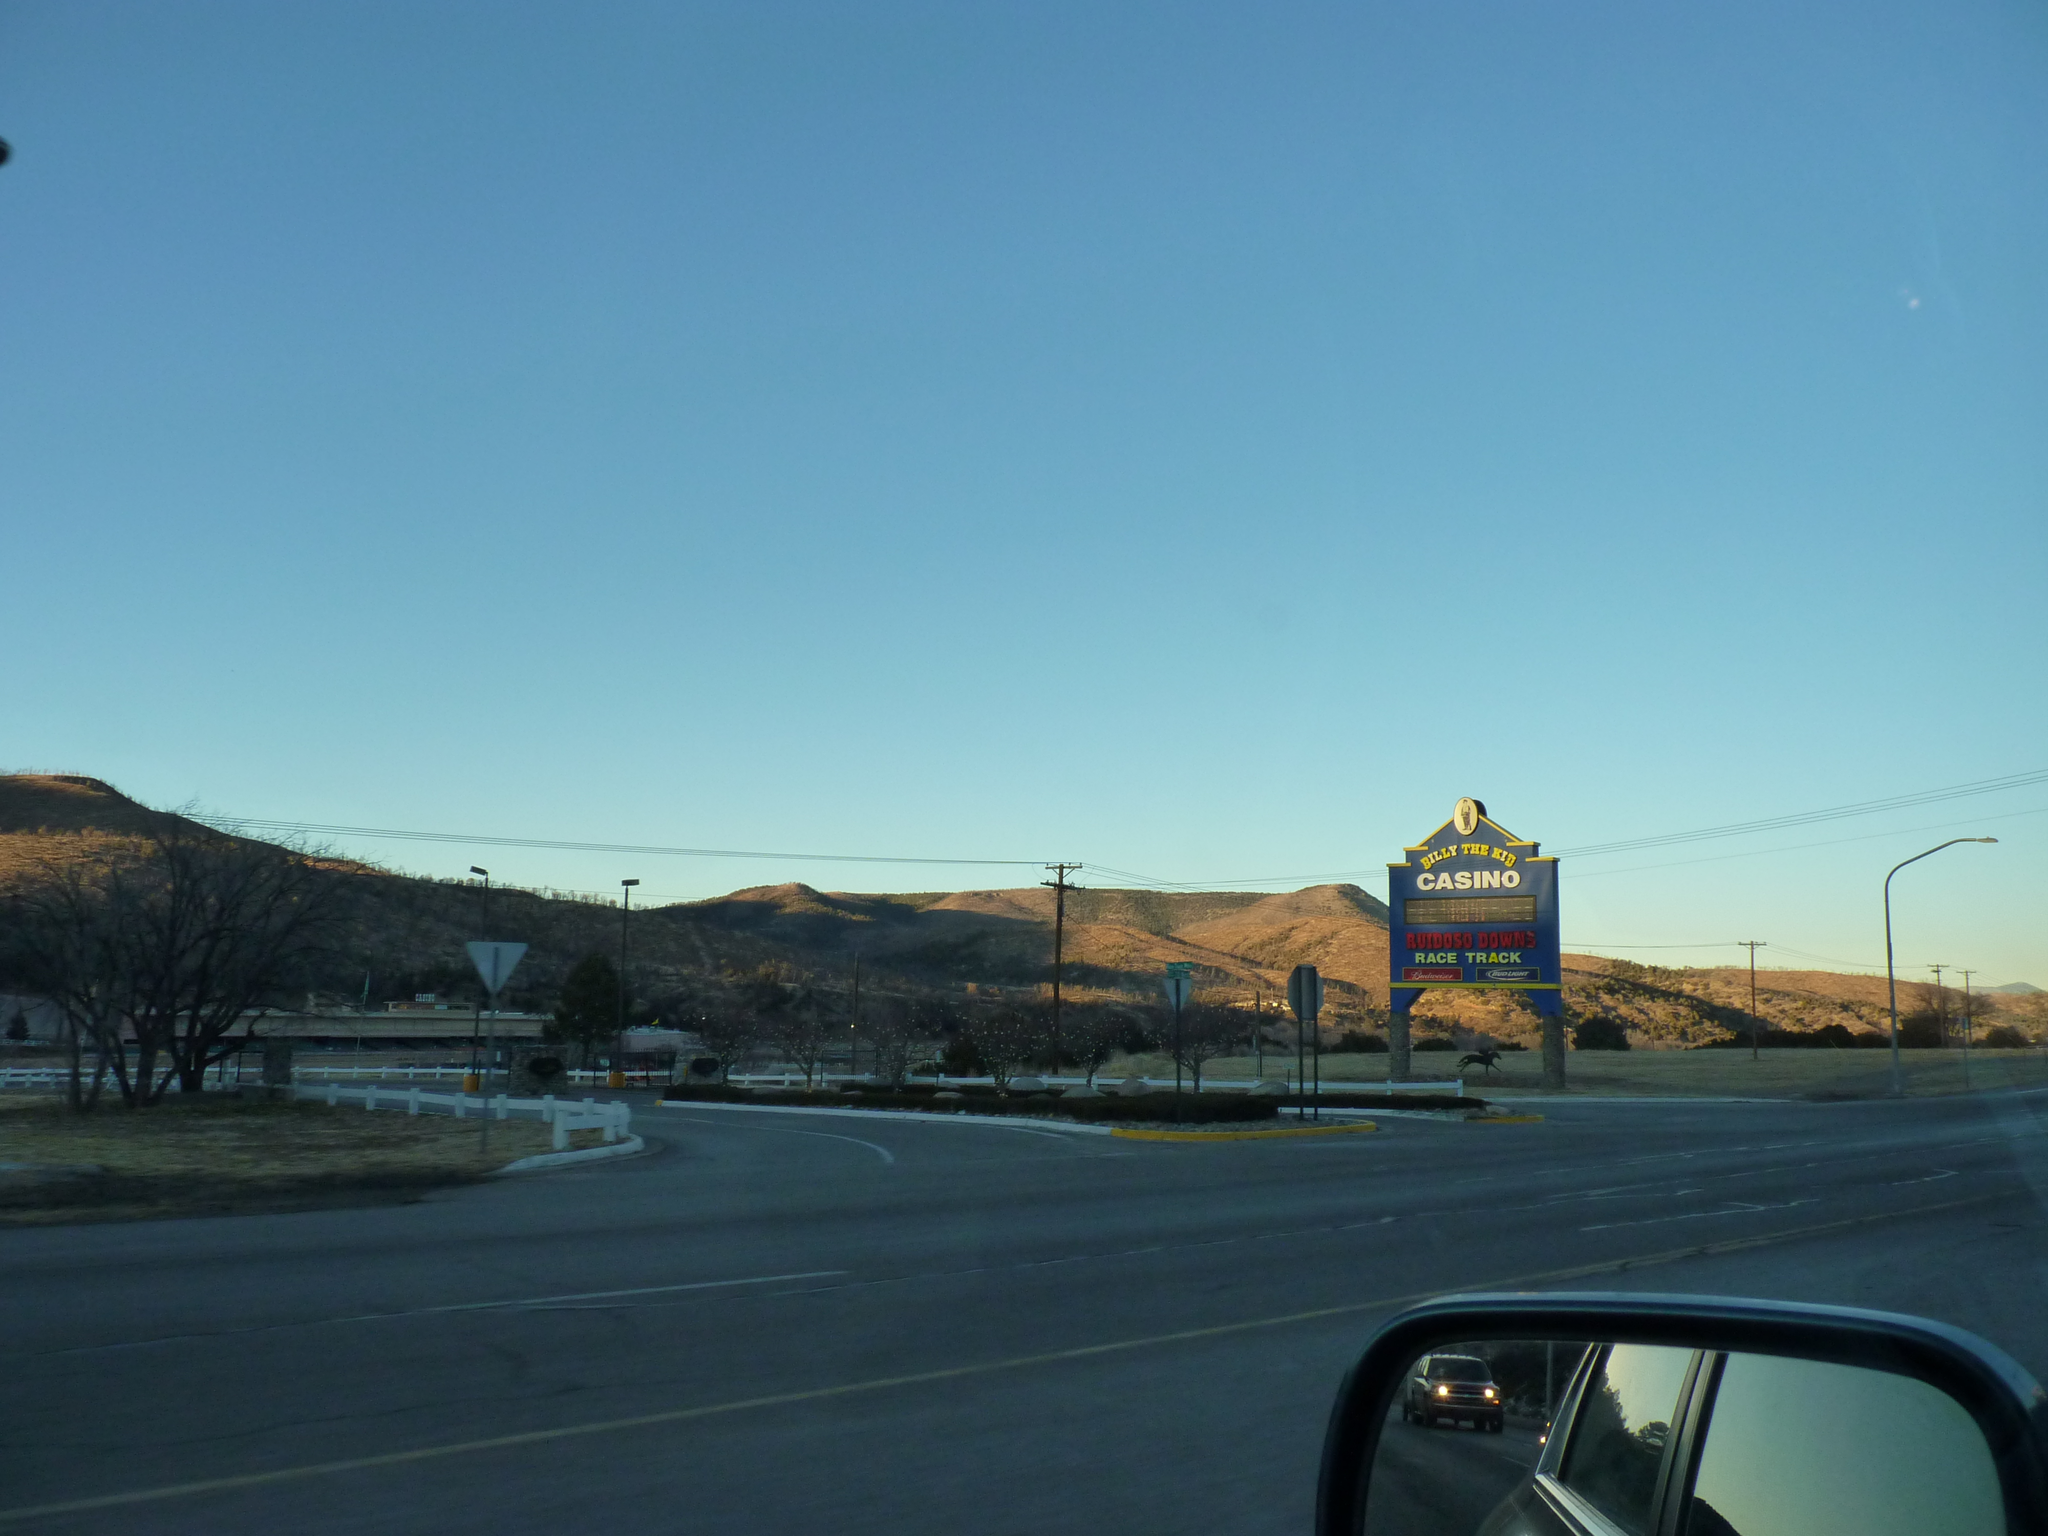Describe this image in one or two sentences. At the bottom of the picture, we see a mirror from which we can see a moving car. Beside that, we see the road. There are trees and street lights. Beside that, we see a board with some text written on it. There are hills in the background. At the top of the picture, we see the sky, which is blue in color. 